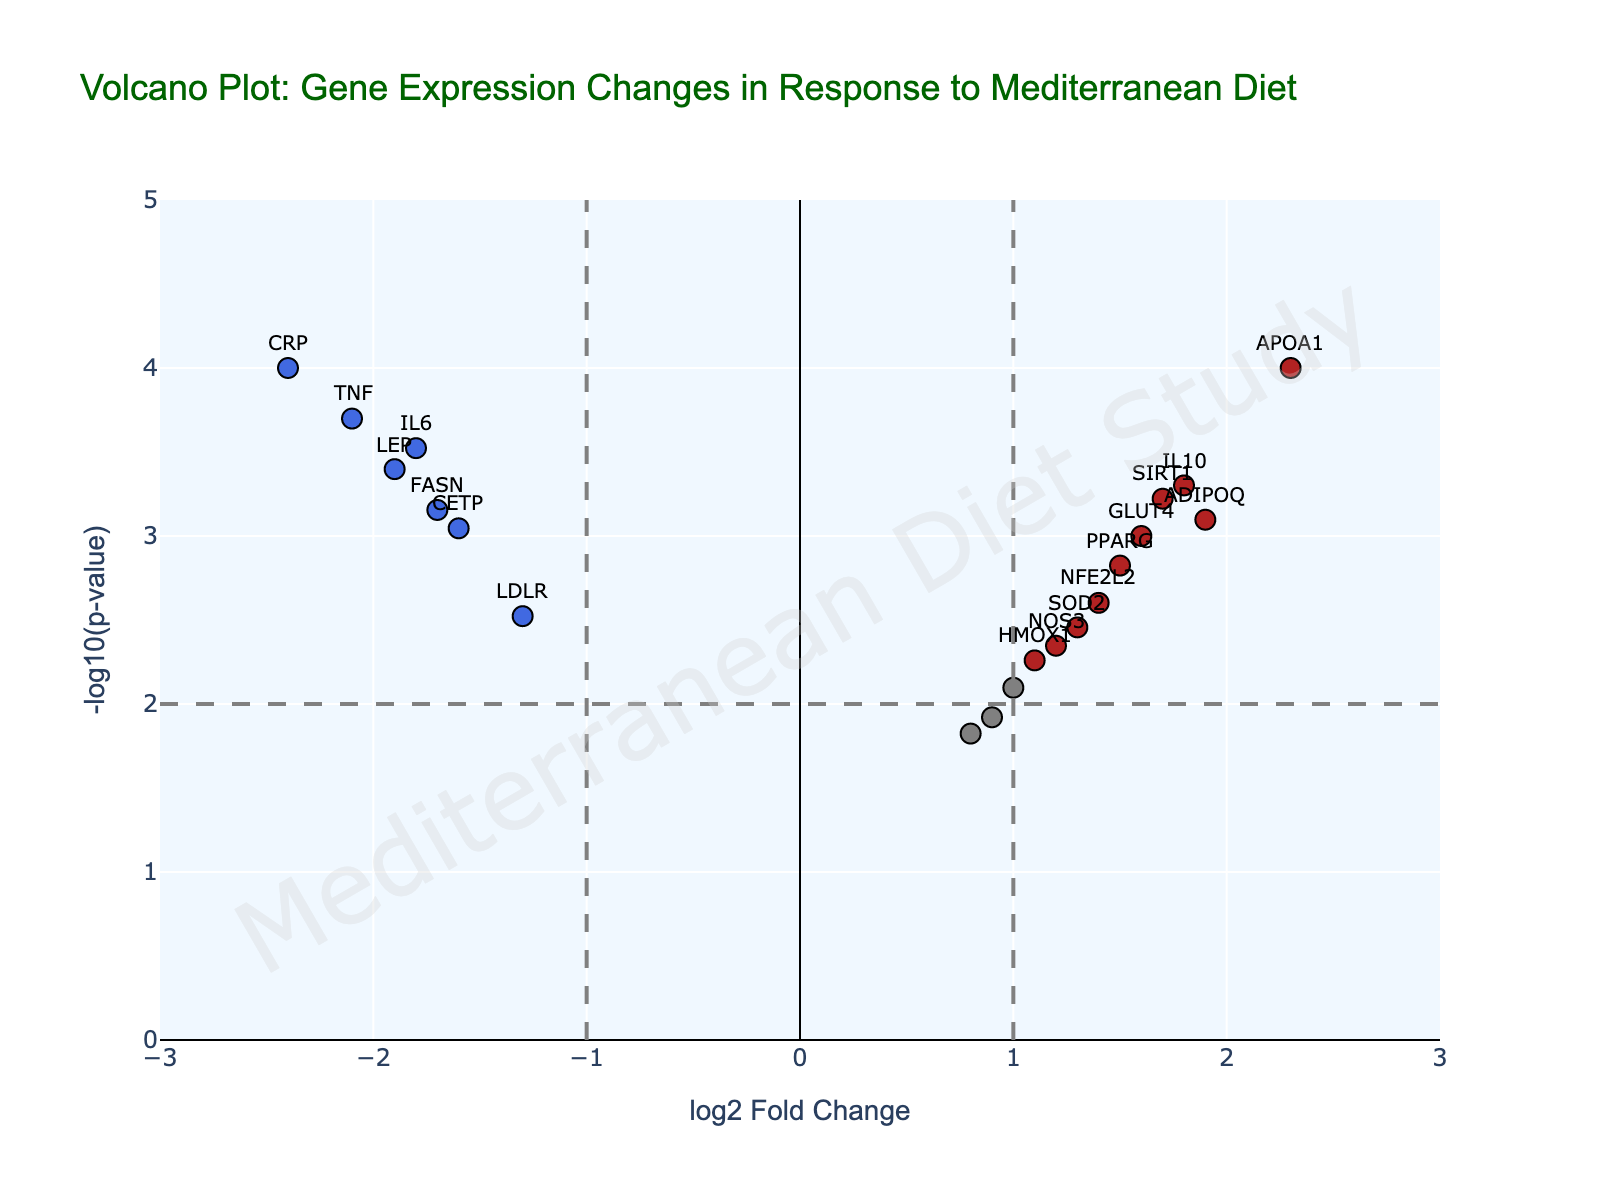What is the title of the plot? The title of the plot is found at the top center of the figure. By reading this title, one can determine what the figure is about.
Answer: Volcano Plot: Gene Expression Changes in Response to Mediterranean Diet What does the x-axis represent? The x-axis represents the log2 Fold Change. This is a measure of the change in gene expression levels.
Answer: log2 Fold Change How many genes are up-regulated? Up-regulated genes are marked in firebrick (red) color and have a positive log2 Fold Change greater than the threshold of 1 with a p-value less than 0.01. Count these points. By visual inspection, there are several markers in red.
Answer: 6 How many genes are significantly down-regulated? Down-regulated genes are marked in royal blue color and have a negative log2 Fold Change less than the threshold of -1 with a p-value less than 0.01. Count these points.
Answer: 5 Which gene shows the highest log2 Fold Change? Identify the point on the x-axis with the highest positive value and check its label. This gene has the highest increase in expression.
Answer: APOA1 Which gene has the most significant p-value? The most significant p-value corresponds to the highest -log10(p-value). Identify the point that is highest on the y-axis and check its label.
Answer: CRP What is the y-axis range? The range of the y-axis can be deduced by looking at the lowest and highest values marked on it.
Answer: 0 to 5 Are there any genes with a log2 Fold Change between -1 and 1? Check the points within the range -1 to 1 on the x-axis and ensure they fall within these bounds. If no points labeled 'firebrick' or 'royalblue', then there are genes marked in gray.
Answer: Yes How is the significance threshold indicated visually on this plot? The significance threshold line can be identified by a dashed line drawn horizontally on the y-axis.
Answer: Horizontal dashed line at a certain y-value What is the log2 Fold Change and p-value for the gene IL6? By hovering over the point labeled for IL6, locate the hover text that displays its log2 Fold Change and p-value.
Answer: log2 Fold Change: -1.8, p-value: 0.0003 